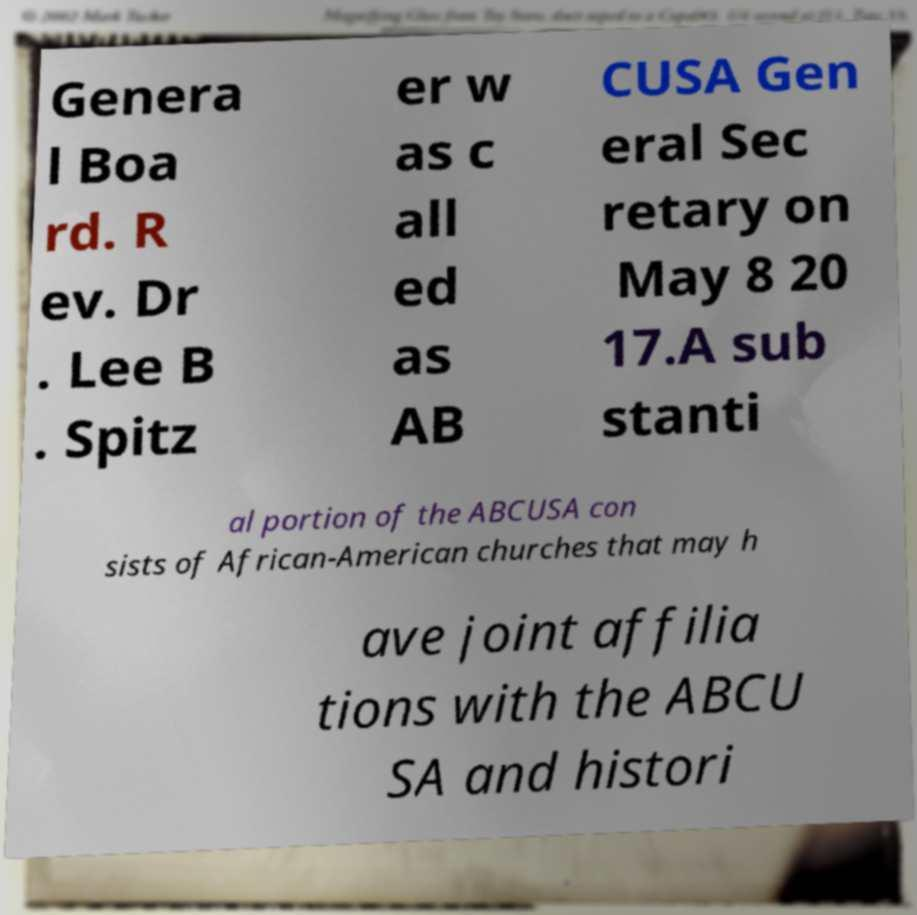For documentation purposes, I need the text within this image transcribed. Could you provide that? Genera l Boa rd. R ev. Dr . Lee B . Spitz er w as c all ed as AB CUSA Gen eral Sec retary on May 8 20 17.A sub stanti al portion of the ABCUSA con sists of African-American churches that may h ave joint affilia tions with the ABCU SA and histori 